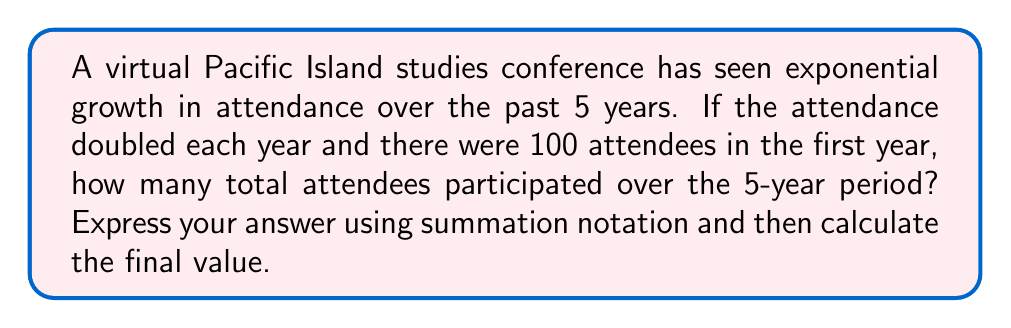Could you help me with this problem? Let's approach this step-by-step:

1) First, let's define our sequence. The number of attendees for each year can be represented as:

   Year 1: $100$
   Year 2: $100 \cdot 2^1 = 200$
   Year 3: $100 \cdot 2^2 = 400$
   Year 4: $100 \cdot 2^3 = 800$
   Year 5: $100 \cdot 2^4 = 1600$

2) We can express this sequence generally as $100 \cdot 2^{n-1}$, where $n$ is the year number.

3) To find the total number of attendees over 5 years, we need to sum this sequence from $n=1$ to $n=5$. We can express this using summation notation:

   $$\sum_{n=1}^{5} 100 \cdot 2^{n-1}$$

4) To calculate this sum, we can use the formula for the sum of a geometric series:
   
   $$S_n = a\frac{1-r^n}{1-r}$$

   where $a$ is the first term, $r$ is the common ratio, and $n$ is the number of terms.

5) In our case:
   $a = 100$
   $r = 2$
   $n = 5$

6) Plugging these values into the formula:

   $$S_5 = 100\frac{1-2^5}{1-2} = 100\frac{1-32}{-1} = 100 \cdot 31 = 3100$$

Therefore, the total number of attendees over the 5-year period is 3100.
Answer: $$\sum_{n=1}^{5} 100 \cdot 2^{n-1} = 3100$$ 